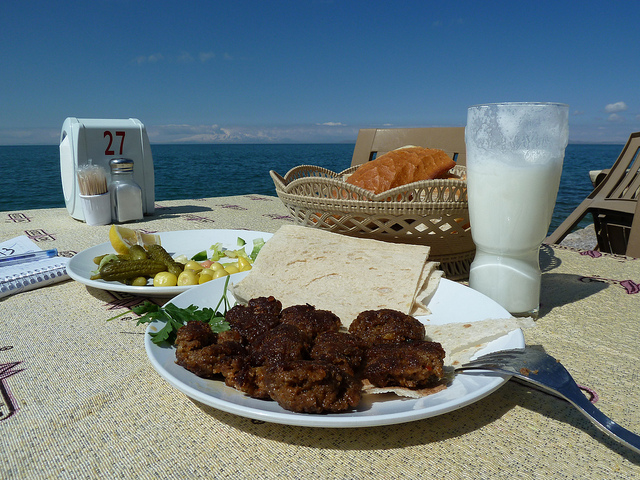Imagine if this table could talk. What stories would it share? If this table could talk, it would share tales of countless moments – from romantic sunset dinners where promises were made, to solitary lunch breaks where people found solace in solitude. It would speak of the laughter of friends reunited and the silent tears of those pondering their life's journey. This table, weathered by the sea breeze, is a silent witness to the ebb and flow of human emotions, reflecting the serenity and unpredictability of the ocean before it. Create a whimsical story involving an enchanted sea-side restaurant. Once upon a time, in a small seaside village, there was an enchanted restaurant that only appeared during the full moon. The restaurant, named ‘Luna Del Mare,’ was known for its magical dishes that had the power to grant wishes. Each full moon night, people from far and wide would gather in hopes of tasting the enchanted meals. A humble fisherman, longing for adventure, stumbled upon the restaurant one fateful night. As he dined on a plate of enchanted seafood, he wished for a life of excitement and exploration. The very next morning, he found himself aboard a majestic, magical ship, ready to sail the seven seas. Luna Del Mare had once again fulfilled a heartfelt desire, proving that magic exists in the most unexpected places. 